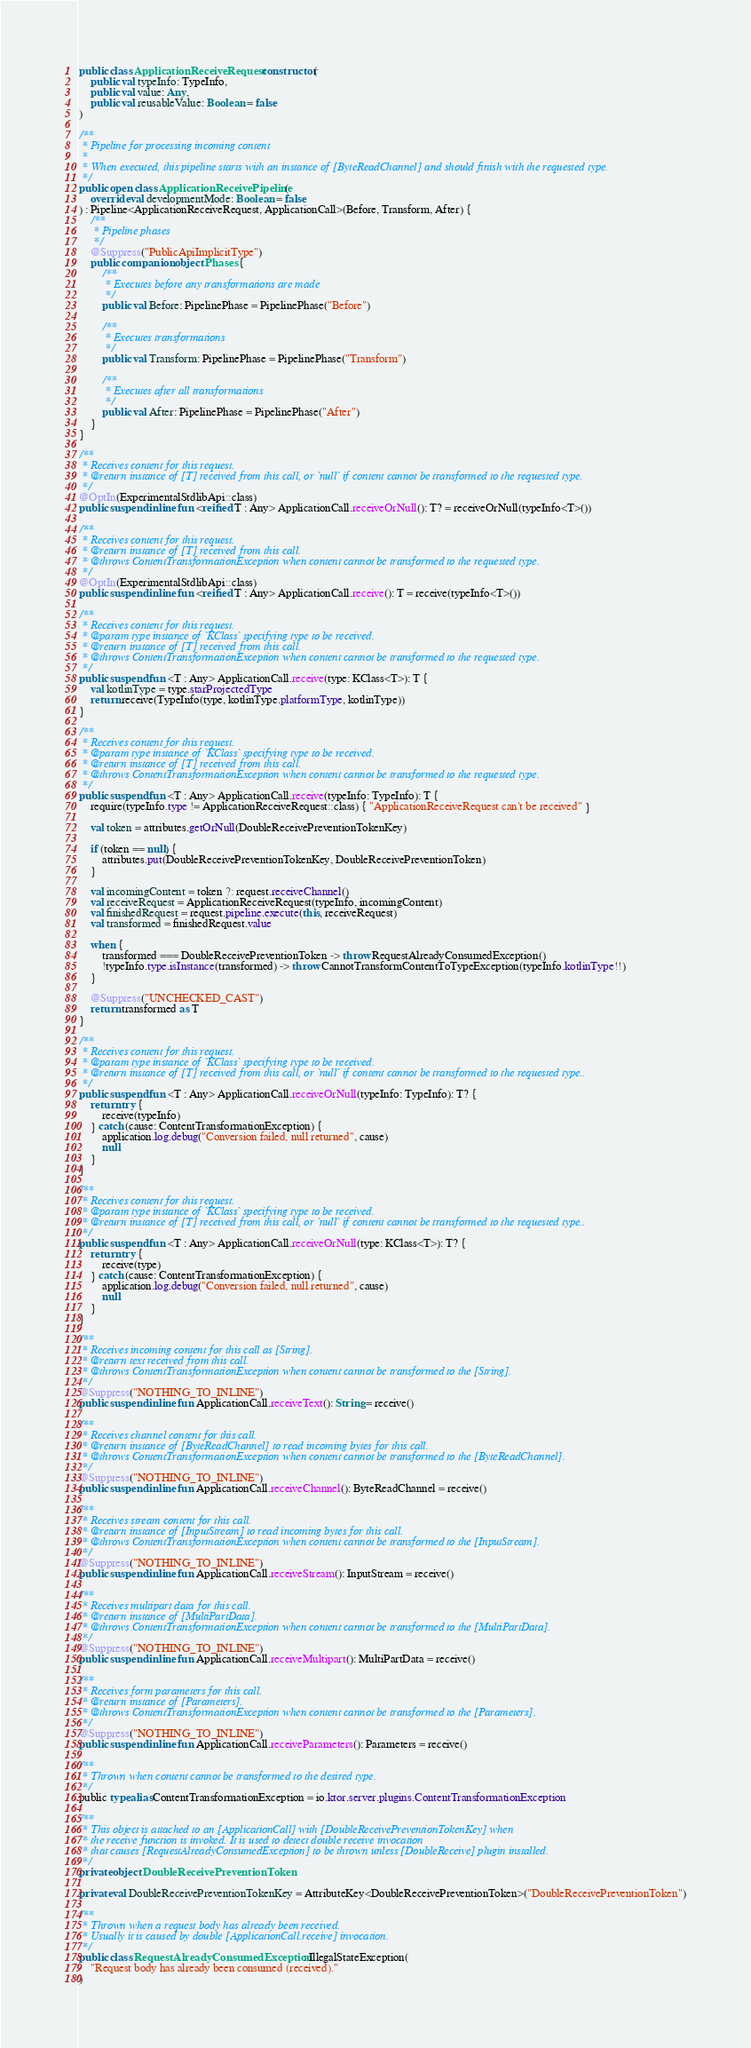<code> <loc_0><loc_0><loc_500><loc_500><_Kotlin_>public class ApplicationReceiveRequest constructor(
    public val typeInfo: TypeInfo,
    public val value: Any,
    public val reusableValue: Boolean = false
)

/**
 * Pipeline for processing incoming content
 *
 * When executed, this pipeline starts with an instance of [ByteReadChannel] and should finish with the requested type.
 */
public open class ApplicationReceivePipeline(
    override val developmentMode: Boolean = false
) : Pipeline<ApplicationReceiveRequest, ApplicationCall>(Before, Transform, After) {
    /**
     * Pipeline phases
     */
    @Suppress("PublicApiImplicitType")
    public companion object Phases {
        /**
         * Executes before any transformations are made
         */
        public val Before: PipelinePhase = PipelinePhase("Before")

        /**
         * Executes transformations
         */
        public val Transform: PipelinePhase = PipelinePhase("Transform")

        /**
         * Executes after all transformations
         */
        public val After: PipelinePhase = PipelinePhase("After")
    }
}

/**
 * Receives content for this request.
 * @return instance of [T] received from this call, or `null` if content cannot be transformed to the requested type.
 */
@OptIn(ExperimentalStdlibApi::class)
public suspend inline fun <reified T : Any> ApplicationCall.receiveOrNull(): T? = receiveOrNull(typeInfo<T>())

/**
 * Receives content for this request.
 * @return instance of [T] received from this call.
 * @throws ContentTransformationException when content cannot be transformed to the requested type.
 */
@OptIn(ExperimentalStdlibApi::class)
public suspend inline fun <reified T : Any> ApplicationCall.receive(): T = receive(typeInfo<T>())

/**
 * Receives content for this request.
 * @param type instance of `KClass` specifying type to be received.
 * @return instance of [T] received from this call.
 * @throws ContentTransformationException when content cannot be transformed to the requested type.
 */
public suspend fun <T : Any> ApplicationCall.receive(type: KClass<T>): T {
    val kotlinType = type.starProjectedType
    return receive(TypeInfo(type, kotlinType.platformType, kotlinType))
}

/**
 * Receives content for this request.
 * @param type instance of `KClass` specifying type to be received.
 * @return instance of [T] received from this call.
 * @throws ContentTransformationException when content cannot be transformed to the requested type.
 */
public suspend fun <T : Any> ApplicationCall.receive(typeInfo: TypeInfo): T {
    require(typeInfo.type != ApplicationReceiveRequest::class) { "ApplicationReceiveRequest can't be received" }

    val token = attributes.getOrNull(DoubleReceivePreventionTokenKey)

    if (token == null) {
        attributes.put(DoubleReceivePreventionTokenKey, DoubleReceivePreventionToken)
    }

    val incomingContent = token ?: request.receiveChannel()
    val receiveRequest = ApplicationReceiveRequest(typeInfo, incomingContent)
    val finishedRequest = request.pipeline.execute(this, receiveRequest)
    val transformed = finishedRequest.value

    when {
        transformed === DoubleReceivePreventionToken -> throw RequestAlreadyConsumedException()
        !typeInfo.type.isInstance(transformed) -> throw CannotTransformContentToTypeException(typeInfo.kotlinType!!)
    }

    @Suppress("UNCHECKED_CAST")
    return transformed as T
}

/**
 * Receives content for this request.
 * @param type instance of `KClass` specifying type to be received.
 * @return instance of [T] received from this call, or `null` if content cannot be transformed to the requested type..
 */
public suspend fun <T : Any> ApplicationCall.receiveOrNull(typeInfo: TypeInfo): T? {
    return try {
        receive(typeInfo)
    } catch (cause: ContentTransformationException) {
        application.log.debug("Conversion failed, null returned", cause)
        null
    }
}

/**
 * Receives content for this request.
 * @param type instance of `KClass` specifying type to be received.
 * @return instance of [T] received from this call, or `null` if content cannot be transformed to the requested type..
 */
public suspend fun <T : Any> ApplicationCall.receiveOrNull(type: KClass<T>): T? {
    return try {
        receive(type)
    } catch (cause: ContentTransformationException) {
        application.log.debug("Conversion failed, null returned", cause)
        null
    }
}

/**
 * Receives incoming content for this call as [String].
 * @return text received from this call.
 * @throws ContentTransformationException when content cannot be transformed to the [String].
 */
@Suppress("NOTHING_TO_INLINE")
public suspend inline fun ApplicationCall.receiveText(): String = receive()

/**
 * Receives channel content for this call.
 * @return instance of [ByteReadChannel] to read incoming bytes for this call.
 * @throws ContentTransformationException when content cannot be transformed to the [ByteReadChannel].
 */
@Suppress("NOTHING_TO_INLINE")
public suspend inline fun ApplicationCall.receiveChannel(): ByteReadChannel = receive()

/**
 * Receives stream content for this call.
 * @return instance of [InputStream] to read incoming bytes for this call.
 * @throws ContentTransformationException when content cannot be transformed to the [InputStream].
 */
@Suppress("NOTHING_TO_INLINE")
public suspend inline fun ApplicationCall.receiveStream(): InputStream = receive()

/**
 * Receives multipart data for this call.
 * @return instance of [MultiPartData].
 * @throws ContentTransformationException when content cannot be transformed to the [MultiPartData].
 */
@Suppress("NOTHING_TO_INLINE")
public suspend inline fun ApplicationCall.receiveMultipart(): MultiPartData = receive()

/**
 * Receives form parameters for this call.
 * @return instance of [Parameters].
 * @throws ContentTransformationException when content cannot be transformed to the [Parameters].
 */
@Suppress("NOTHING_TO_INLINE")
public suspend inline fun ApplicationCall.receiveParameters(): Parameters = receive()

/**
 * Thrown when content cannot be transformed to the desired type.
 */
public typealias ContentTransformationException = io.ktor.server.plugins.ContentTransformationException

/**
 * This object is attached to an [ApplicationCall] with [DoubleReceivePreventionTokenKey] when
 * the receive function is invoked. It is used to detect double receive invocation
 * that causes [RequestAlreadyConsumedException] to be thrown unless [DoubleReceive] plugin installed.
 */
private object DoubleReceivePreventionToken

private val DoubleReceivePreventionTokenKey = AttributeKey<DoubleReceivePreventionToken>("DoubleReceivePreventionToken")

/**
 * Thrown when a request body has already been received.
 * Usually it is caused by double [ApplicationCall.receive] invocation.
 */
public class RequestAlreadyConsumedException : IllegalStateException(
    "Request body has already been consumed (received)."
)
</code> 